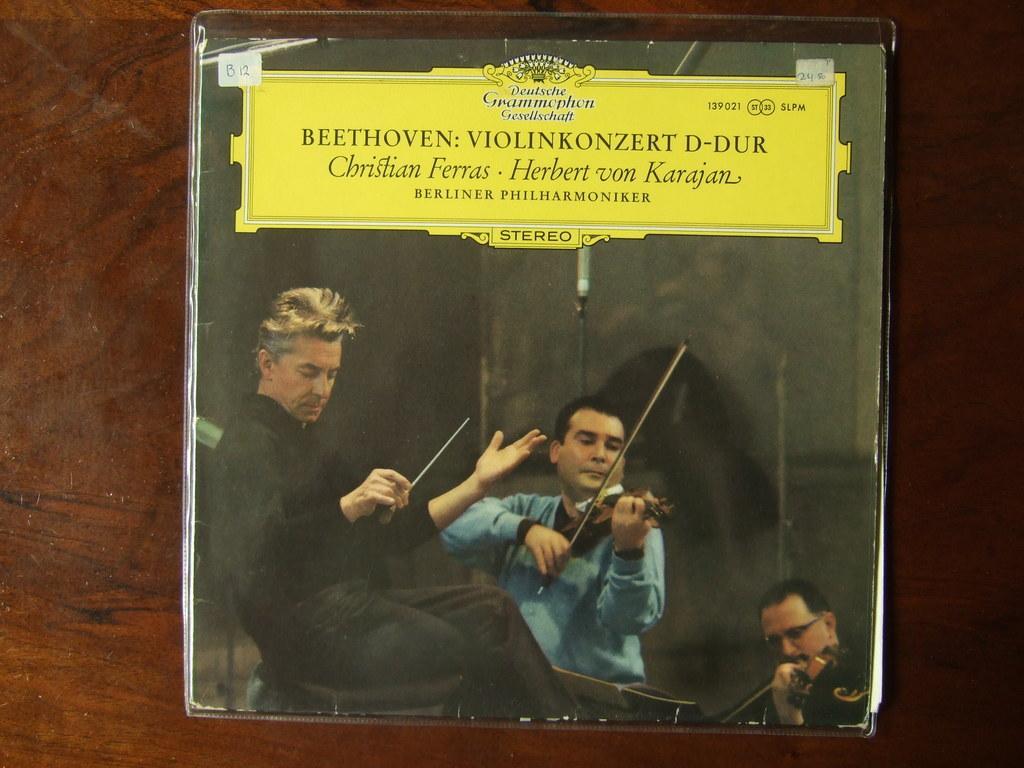How would you summarize this image in a sentence or two? In this picture we can see a board on the wooden surface, in this board we can see people, among them there are two people playing musical instruments and we can see text. 